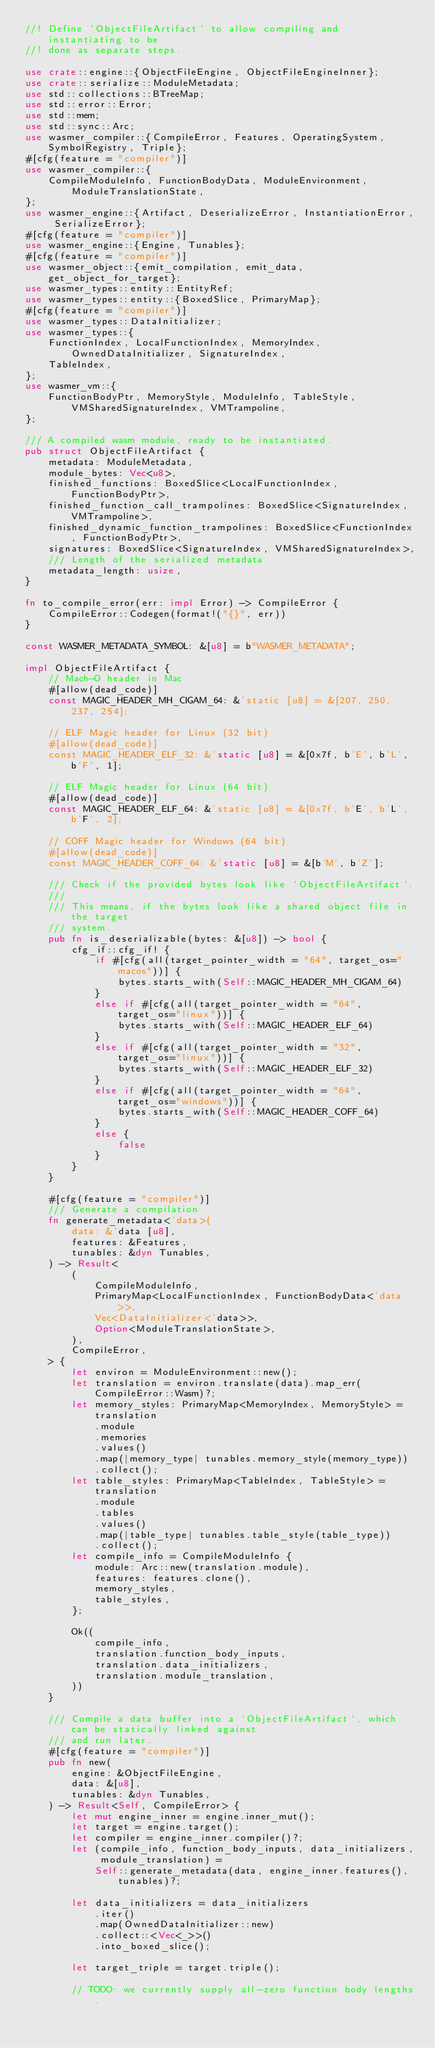Convert code to text. <code><loc_0><loc_0><loc_500><loc_500><_Rust_>//! Define `ObjectFileArtifact` to allow compiling and instantiating to be
//! done as separate steps.

use crate::engine::{ObjectFileEngine, ObjectFileEngineInner};
use crate::serialize::ModuleMetadata;
use std::collections::BTreeMap;
use std::error::Error;
use std::mem;
use std::sync::Arc;
use wasmer_compiler::{CompileError, Features, OperatingSystem, SymbolRegistry, Triple};
#[cfg(feature = "compiler")]
use wasmer_compiler::{
    CompileModuleInfo, FunctionBodyData, ModuleEnvironment, ModuleTranslationState,
};
use wasmer_engine::{Artifact, DeserializeError, InstantiationError, SerializeError};
#[cfg(feature = "compiler")]
use wasmer_engine::{Engine, Tunables};
#[cfg(feature = "compiler")]
use wasmer_object::{emit_compilation, emit_data, get_object_for_target};
use wasmer_types::entity::EntityRef;
use wasmer_types::entity::{BoxedSlice, PrimaryMap};
#[cfg(feature = "compiler")]
use wasmer_types::DataInitializer;
use wasmer_types::{
    FunctionIndex, LocalFunctionIndex, MemoryIndex, OwnedDataInitializer, SignatureIndex,
    TableIndex,
};
use wasmer_vm::{
    FunctionBodyPtr, MemoryStyle, ModuleInfo, TableStyle, VMSharedSignatureIndex, VMTrampoline,
};

/// A compiled wasm module, ready to be instantiated.
pub struct ObjectFileArtifact {
    metadata: ModuleMetadata,
    module_bytes: Vec<u8>,
    finished_functions: BoxedSlice<LocalFunctionIndex, FunctionBodyPtr>,
    finished_function_call_trampolines: BoxedSlice<SignatureIndex, VMTrampoline>,
    finished_dynamic_function_trampolines: BoxedSlice<FunctionIndex, FunctionBodyPtr>,
    signatures: BoxedSlice<SignatureIndex, VMSharedSignatureIndex>,
    /// Length of the serialized metadata
    metadata_length: usize,
}

fn to_compile_error(err: impl Error) -> CompileError {
    CompileError::Codegen(format!("{}", err))
}

const WASMER_METADATA_SYMBOL: &[u8] = b"WASMER_METADATA";

impl ObjectFileArtifact {
    // Mach-O header in Mac
    #[allow(dead_code)]
    const MAGIC_HEADER_MH_CIGAM_64: &'static [u8] = &[207, 250, 237, 254];

    // ELF Magic header for Linux (32 bit)
    #[allow(dead_code)]
    const MAGIC_HEADER_ELF_32: &'static [u8] = &[0x7f, b'E', b'L', b'F', 1];

    // ELF Magic header for Linux (64 bit)
    #[allow(dead_code)]
    const MAGIC_HEADER_ELF_64: &'static [u8] = &[0x7f, b'E', b'L', b'F', 2];

    // COFF Magic header for Windows (64 bit)
    #[allow(dead_code)]
    const MAGIC_HEADER_COFF_64: &'static [u8] = &[b'M', b'Z'];

    /// Check if the provided bytes look like `ObjectFileArtifact`.
    ///
    /// This means, if the bytes look like a shared object file in the target
    /// system.
    pub fn is_deserializable(bytes: &[u8]) -> bool {
        cfg_if::cfg_if! {
            if #[cfg(all(target_pointer_width = "64", target_os="macos"))] {
                bytes.starts_with(Self::MAGIC_HEADER_MH_CIGAM_64)
            }
            else if #[cfg(all(target_pointer_width = "64", target_os="linux"))] {
                bytes.starts_with(Self::MAGIC_HEADER_ELF_64)
            }
            else if #[cfg(all(target_pointer_width = "32", target_os="linux"))] {
                bytes.starts_with(Self::MAGIC_HEADER_ELF_32)
            }
            else if #[cfg(all(target_pointer_width = "64", target_os="windows"))] {
                bytes.starts_with(Self::MAGIC_HEADER_COFF_64)
            }
            else {
                false
            }
        }
    }

    #[cfg(feature = "compiler")]
    /// Generate a compilation
    fn generate_metadata<'data>(
        data: &'data [u8],
        features: &Features,
        tunables: &dyn Tunables,
    ) -> Result<
        (
            CompileModuleInfo,
            PrimaryMap<LocalFunctionIndex, FunctionBodyData<'data>>,
            Vec<DataInitializer<'data>>,
            Option<ModuleTranslationState>,
        ),
        CompileError,
    > {
        let environ = ModuleEnvironment::new();
        let translation = environ.translate(data).map_err(CompileError::Wasm)?;
        let memory_styles: PrimaryMap<MemoryIndex, MemoryStyle> = translation
            .module
            .memories
            .values()
            .map(|memory_type| tunables.memory_style(memory_type))
            .collect();
        let table_styles: PrimaryMap<TableIndex, TableStyle> = translation
            .module
            .tables
            .values()
            .map(|table_type| tunables.table_style(table_type))
            .collect();
        let compile_info = CompileModuleInfo {
            module: Arc::new(translation.module),
            features: features.clone(),
            memory_styles,
            table_styles,
        };

        Ok((
            compile_info,
            translation.function_body_inputs,
            translation.data_initializers,
            translation.module_translation,
        ))
    }

    /// Compile a data buffer into a `ObjectFileArtifact`, which can be statically linked against
    /// and run later.
    #[cfg(feature = "compiler")]
    pub fn new(
        engine: &ObjectFileEngine,
        data: &[u8],
        tunables: &dyn Tunables,
    ) -> Result<Self, CompileError> {
        let mut engine_inner = engine.inner_mut();
        let target = engine.target();
        let compiler = engine_inner.compiler()?;
        let (compile_info, function_body_inputs, data_initializers, module_translation) =
            Self::generate_metadata(data, engine_inner.features(), tunables)?;

        let data_initializers = data_initializers
            .iter()
            .map(OwnedDataInitializer::new)
            .collect::<Vec<_>>()
            .into_boxed_slice();

        let target_triple = target.triple();

        // TODO: we currently supply all-zero function body lengths.</code> 